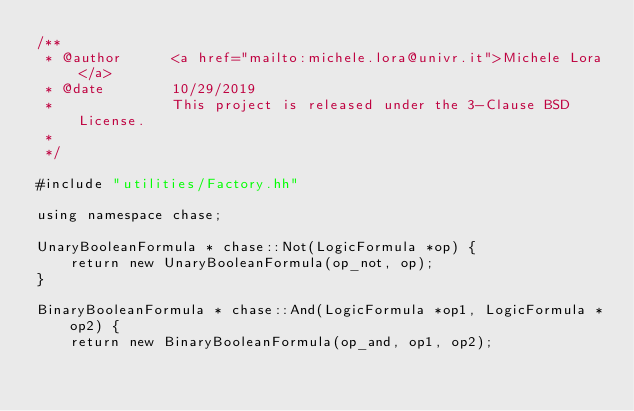Convert code to text. <code><loc_0><loc_0><loc_500><loc_500><_C++_>/**
 * @author      <a href="mailto:michele.lora@univr.it">Michele Lora</a>
 * @date        10/29/2019
 *              This project is released under the 3-Clause BSD License.
 *
 */

#include "utilities/Factory.hh"

using namespace chase;

UnaryBooleanFormula * chase::Not(LogicFormula *op) {
    return new UnaryBooleanFormula(op_not, op);
}

BinaryBooleanFormula * chase::And(LogicFormula *op1, LogicFormula *op2) {
    return new BinaryBooleanFormula(op_and, op1, op2);</code> 